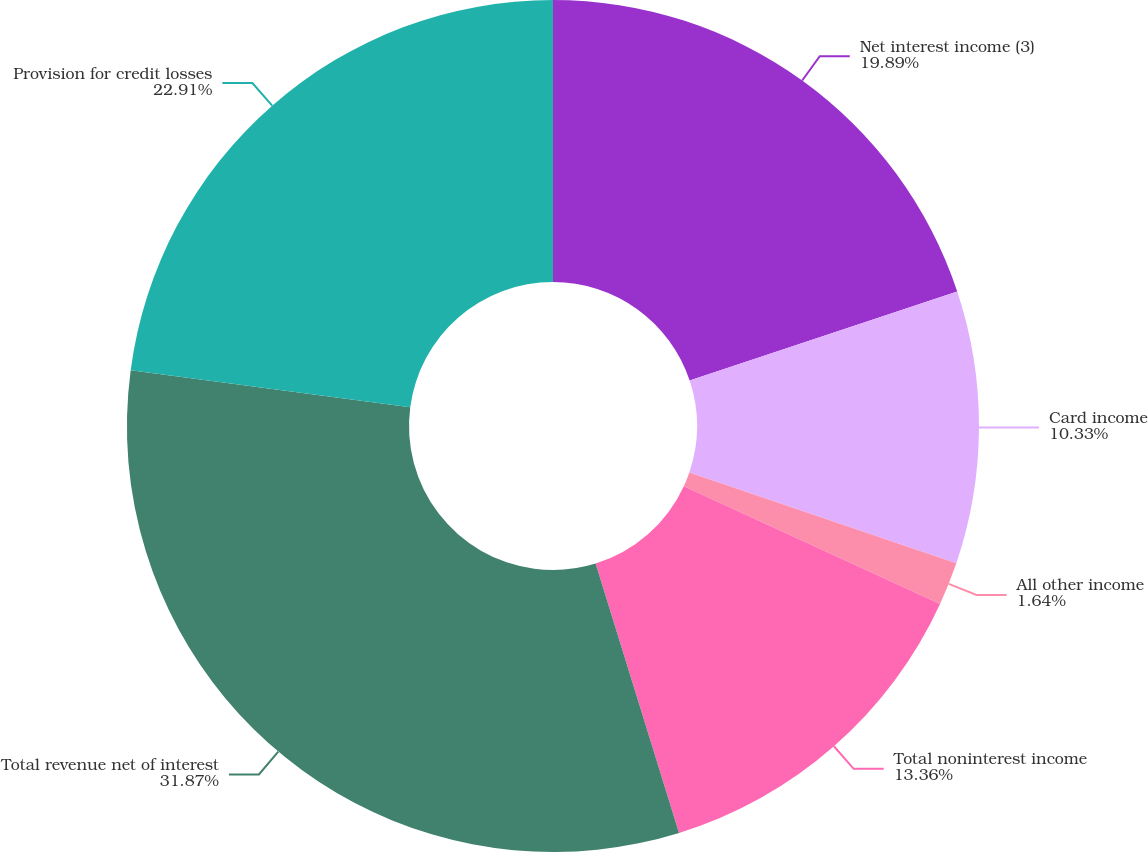<chart> <loc_0><loc_0><loc_500><loc_500><pie_chart><fcel>Net interest income (3)<fcel>Card income<fcel>All other income<fcel>Total noninterest income<fcel>Total revenue net of interest<fcel>Provision for credit losses<nl><fcel>19.89%<fcel>10.33%<fcel>1.64%<fcel>13.36%<fcel>31.87%<fcel>22.91%<nl></chart> 